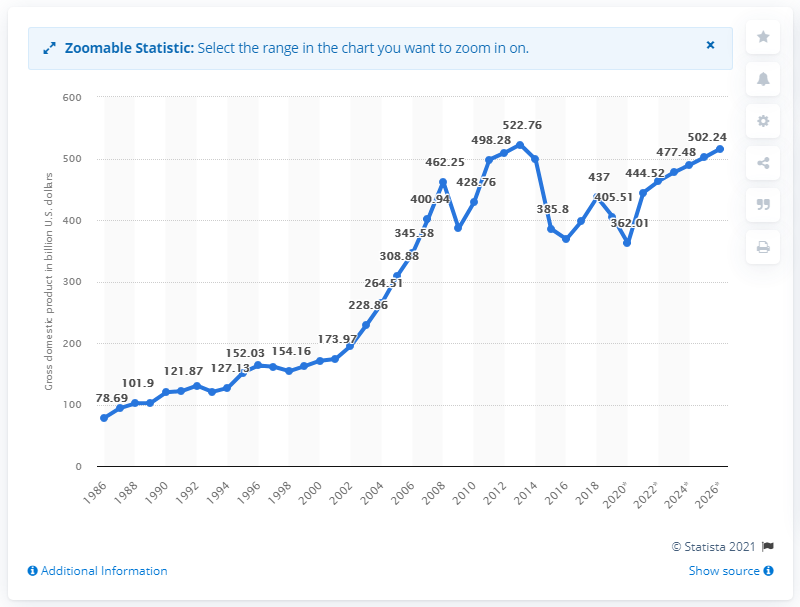Specify some key components in this picture. In 2018, Norway's gross domestic product was approximately 437 billion dollars. 